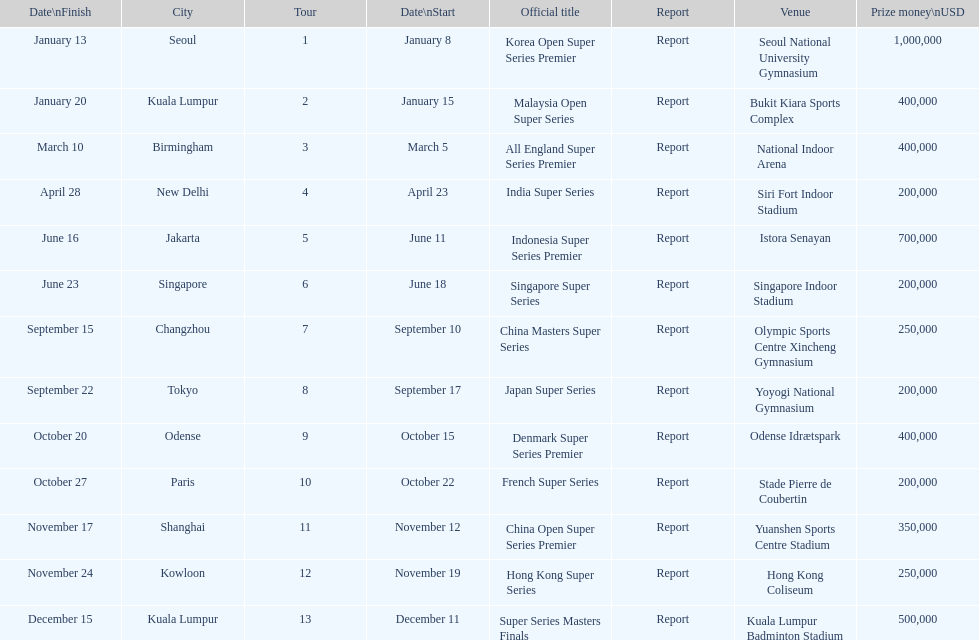What are all the titles? Korea Open Super Series Premier, Malaysia Open Super Series, All England Super Series Premier, India Super Series, Indonesia Super Series Premier, Singapore Super Series, China Masters Super Series, Japan Super Series, Denmark Super Series Premier, French Super Series, China Open Super Series Premier, Hong Kong Super Series, Super Series Masters Finals. When did they take place? January 8, January 15, March 5, April 23, June 11, June 18, September 10, September 17, October 15, October 22, November 12, November 19, December 11. Which title took place in december? Super Series Masters Finals. 